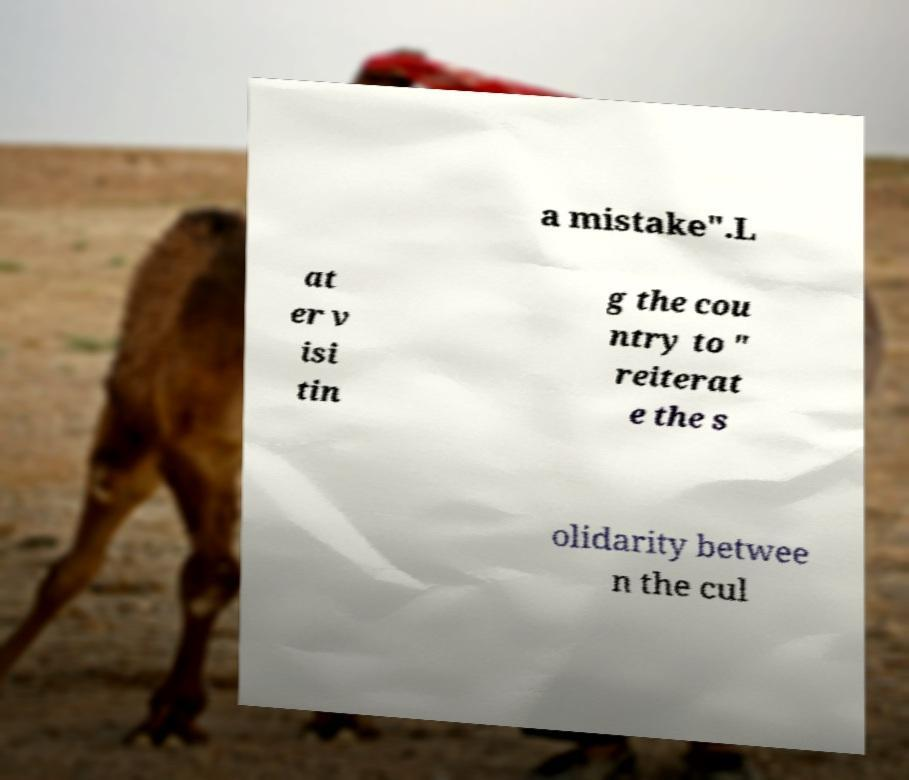Could you assist in decoding the text presented in this image and type it out clearly? a mistake".L at er v isi tin g the cou ntry to " reiterat e the s olidarity betwee n the cul 